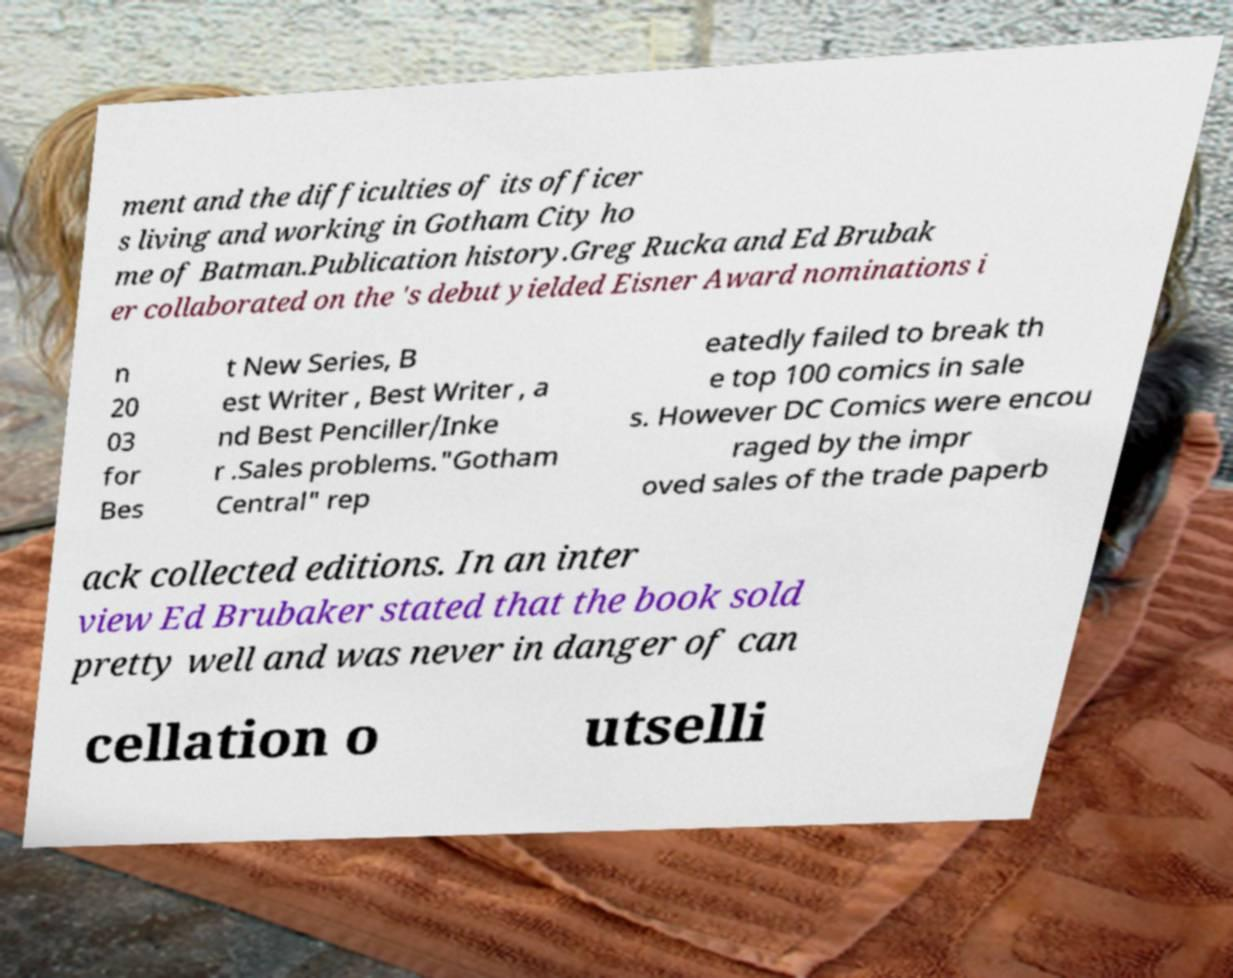Please read and relay the text visible in this image. What does it say? ment and the difficulties of its officer s living and working in Gotham City ho me of Batman.Publication history.Greg Rucka and Ed Brubak er collaborated on the 's debut yielded Eisner Award nominations i n 20 03 for Bes t New Series, B est Writer , Best Writer , a nd Best Penciller/Inke r .Sales problems."Gotham Central" rep eatedly failed to break th e top 100 comics in sale s. However DC Comics were encou raged by the impr oved sales of the trade paperb ack collected editions. In an inter view Ed Brubaker stated that the book sold pretty well and was never in danger of can cellation o utselli 